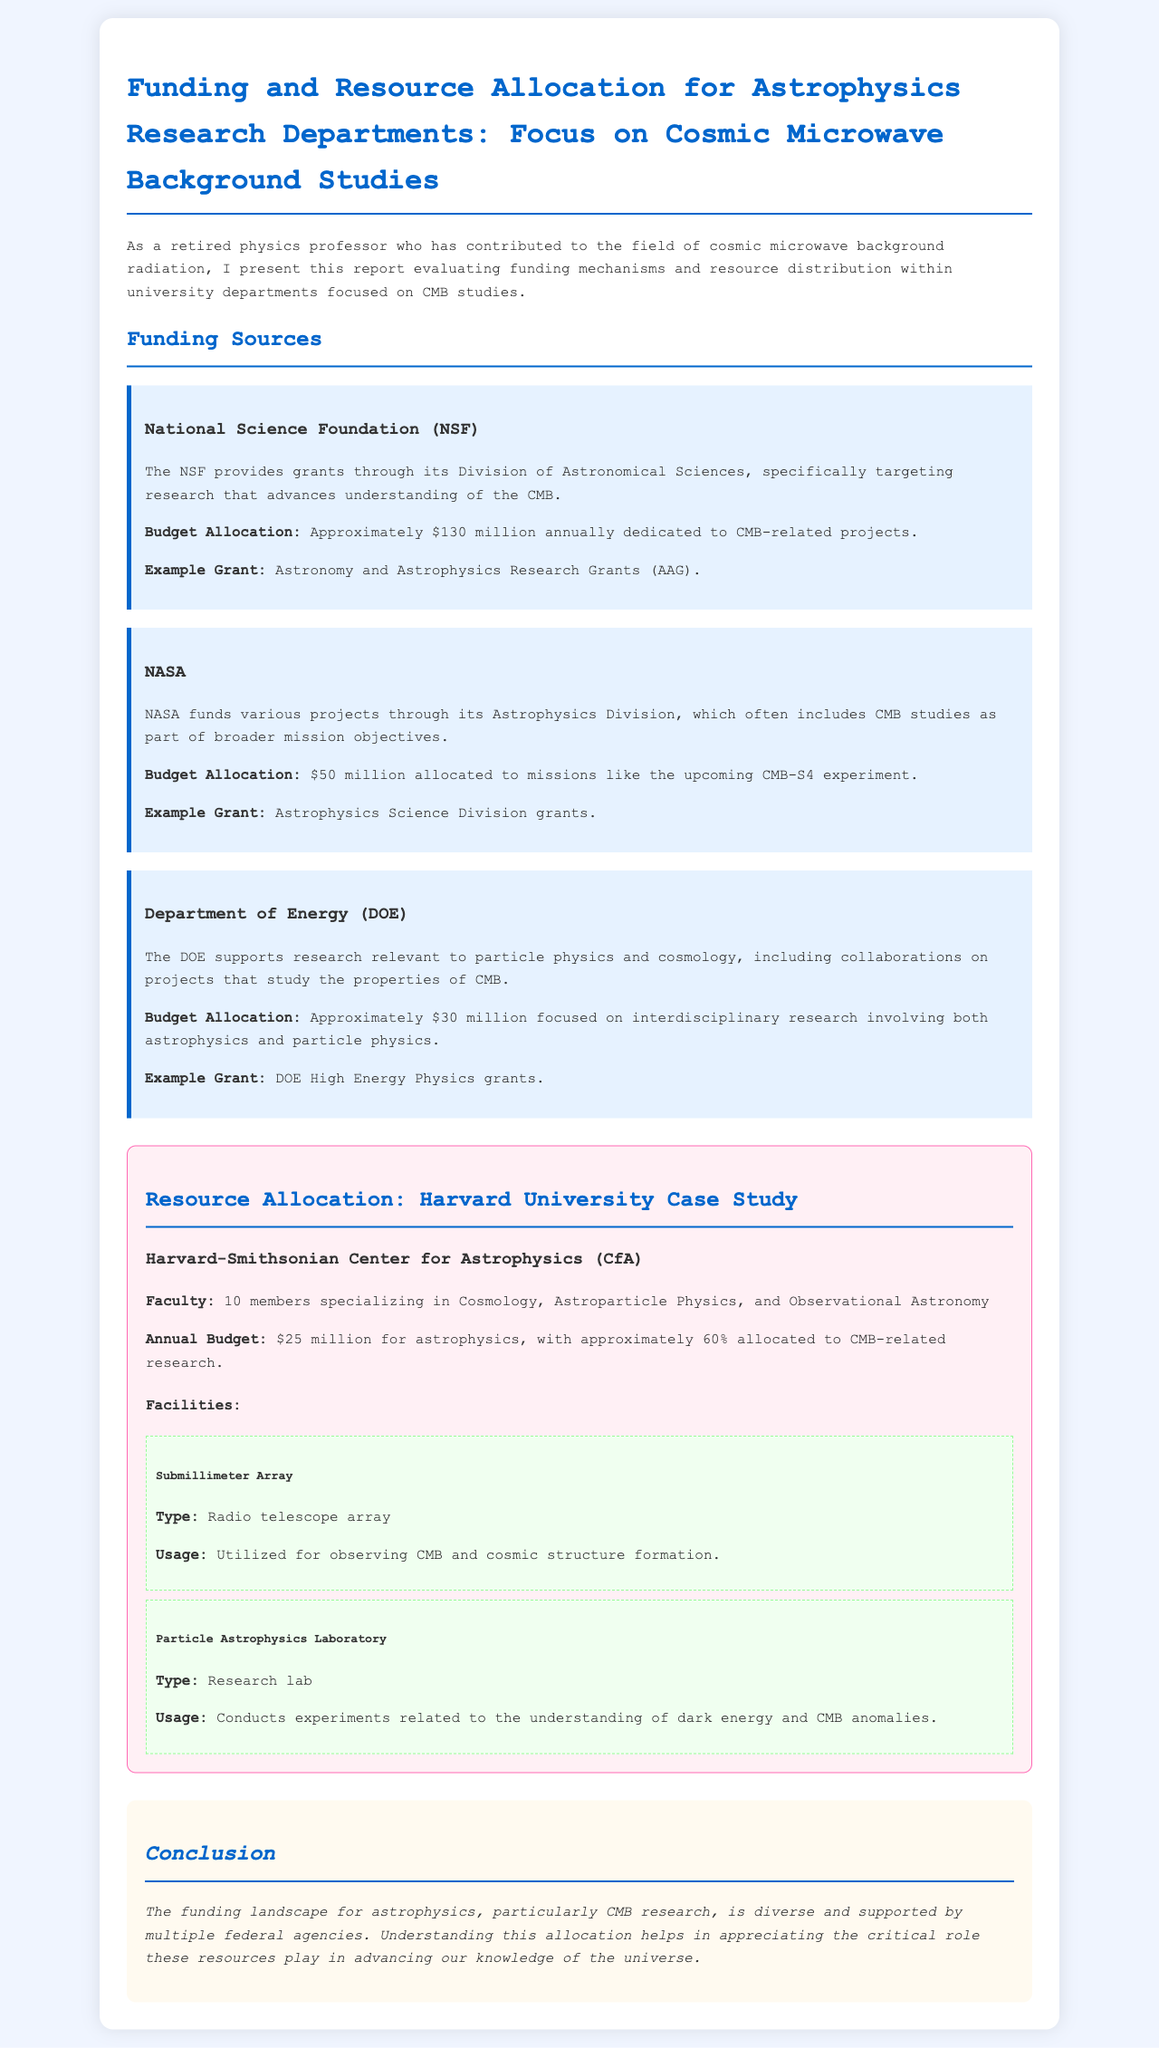What is the annual budget allocated for CMB-related projects by the NSF? The document states that the NSF provides approximately $130 million annually for CMB-related projects.
Answer: $130 million What percentage of Harvard's astrophysics budget is allocated to CMB research? The report mentions that approximately 60% of Harvard's $25 million budget for astrophysics is allocated to CMB-related research.
Answer: 60% Which agency allocates $50 million to the CMB-S4 experiment? The document highlights that NASA allocates $50 million for the CMB-S4 experiment.
Answer: NASA What type of facility is the Submillimeter Array? The report describes the Submillimeter Array as a radio telescope array.
Answer: Radio telescope array How many faculty members at Harvard specialize in Cosmology and related fields? The Harvard-Smithsonian Center for Astrophysics has 10 faculty members specializing in Cosmology and Astroparticle Physics.
Answer: 10 What is the total budget for astrophysics at Harvard University? The document states that Harvard University's annual budget for astrophysics is $25 million.
Answer: $25 million What are the two main facilities mentioned for CMB research at Harvard? The document lists the Submillimeter Array and the Particle Astrophysics Laboratory as the main facilities for CMB research.
Answer: Submillimeter Array and Particle Astrophysics Laboratory What is the budget allocation from the DOE for CMB-related projects? The report indicates that the DOE supports approximately $30 million focused on interdisciplinary research including CMB studies.
Answer: $30 million What type of research does the Particle Astrophysics Laboratory conduct? According to the document, the Particle Astrophysics Laboratory conducts experiments related to dark energy and CMB anomalies.
Answer: Dark energy and CMB anomalies 